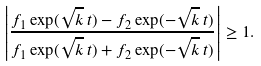Convert formula to latex. <formula><loc_0><loc_0><loc_500><loc_500>\left | \frac { f _ { 1 } \exp ( \sqrt { k } \, t ) - f _ { 2 } \exp ( - \sqrt { k } \, t ) } { f _ { 1 } \exp ( \sqrt { k } \, t ) + f _ { 2 } \exp ( - \sqrt { k } \, t ) } \right | \geq 1 .</formula> 